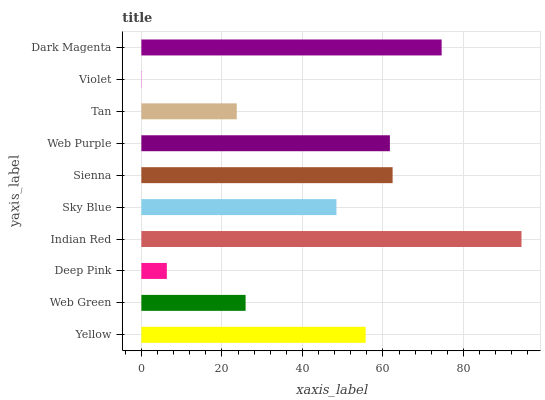Is Violet the minimum?
Answer yes or no. Yes. Is Indian Red the maximum?
Answer yes or no. Yes. Is Web Green the minimum?
Answer yes or no. No. Is Web Green the maximum?
Answer yes or no. No. Is Yellow greater than Web Green?
Answer yes or no. Yes. Is Web Green less than Yellow?
Answer yes or no. Yes. Is Web Green greater than Yellow?
Answer yes or no. No. Is Yellow less than Web Green?
Answer yes or no. No. Is Yellow the high median?
Answer yes or no. Yes. Is Sky Blue the low median?
Answer yes or no. Yes. Is Deep Pink the high median?
Answer yes or no. No. Is Violet the low median?
Answer yes or no. No. 